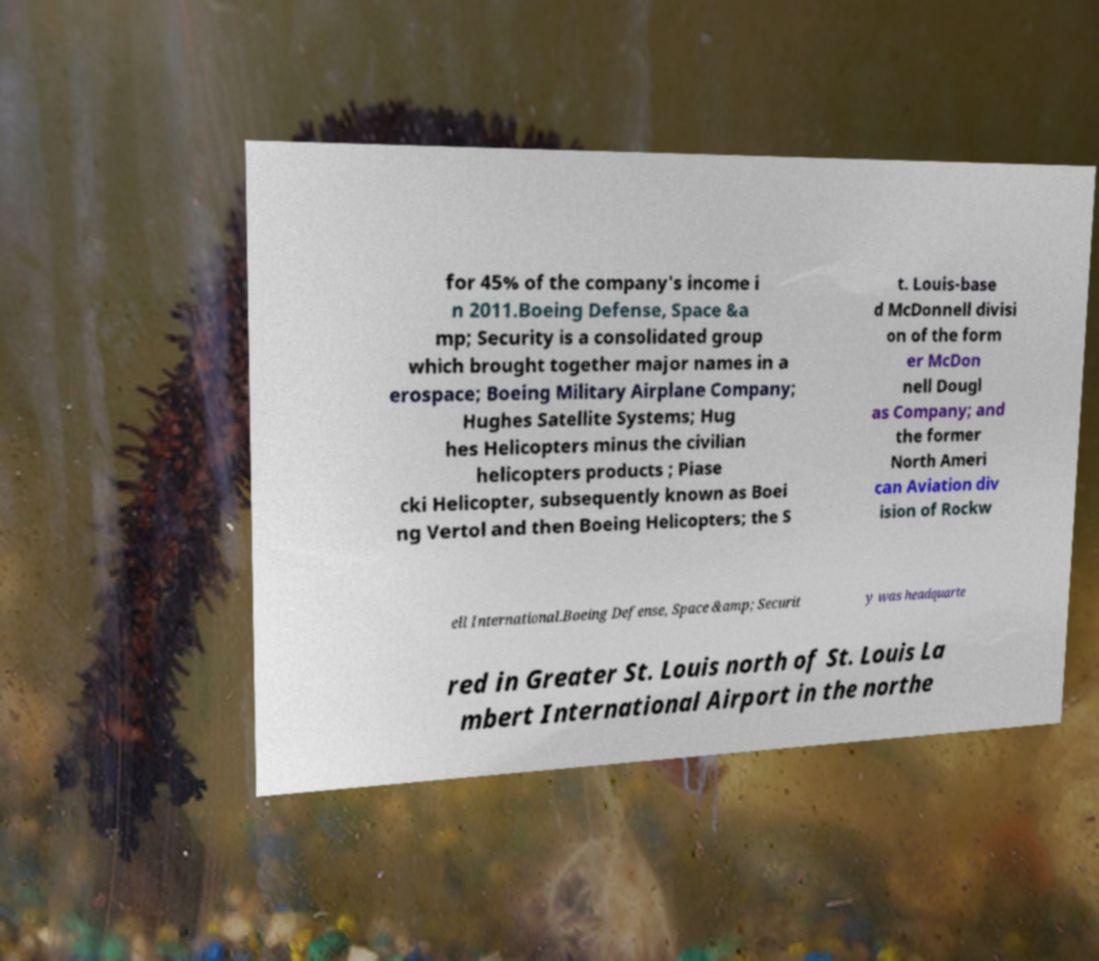For documentation purposes, I need the text within this image transcribed. Could you provide that? for 45% of the company's income i n 2011.Boeing Defense, Space &a mp; Security is a consolidated group which brought together major names in a erospace; Boeing Military Airplane Company; Hughes Satellite Systems; Hug hes Helicopters minus the civilian helicopters products ; Piase cki Helicopter, subsequently known as Boei ng Vertol and then Boeing Helicopters; the S t. Louis-base d McDonnell divisi on of the form er McDon nell Dougl as Company; and the former North Ameri can Aviation div ision of Rockw ell International.Boeing Defense, Space &amp; Securit y was headquarte red in Greater St. Louis north of St. Louis La mbert International Airport in the northe 